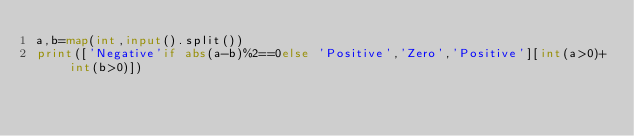Convert code to text. <code><loc_0><loc_0><loc_500><loc_500><_Python_>a,b=map(int,input().split())
print(['Negative'if abs(a-b)%2==0else 'Positive','Zero','Positive'][int(a>0)+int(b>0)])</code> 